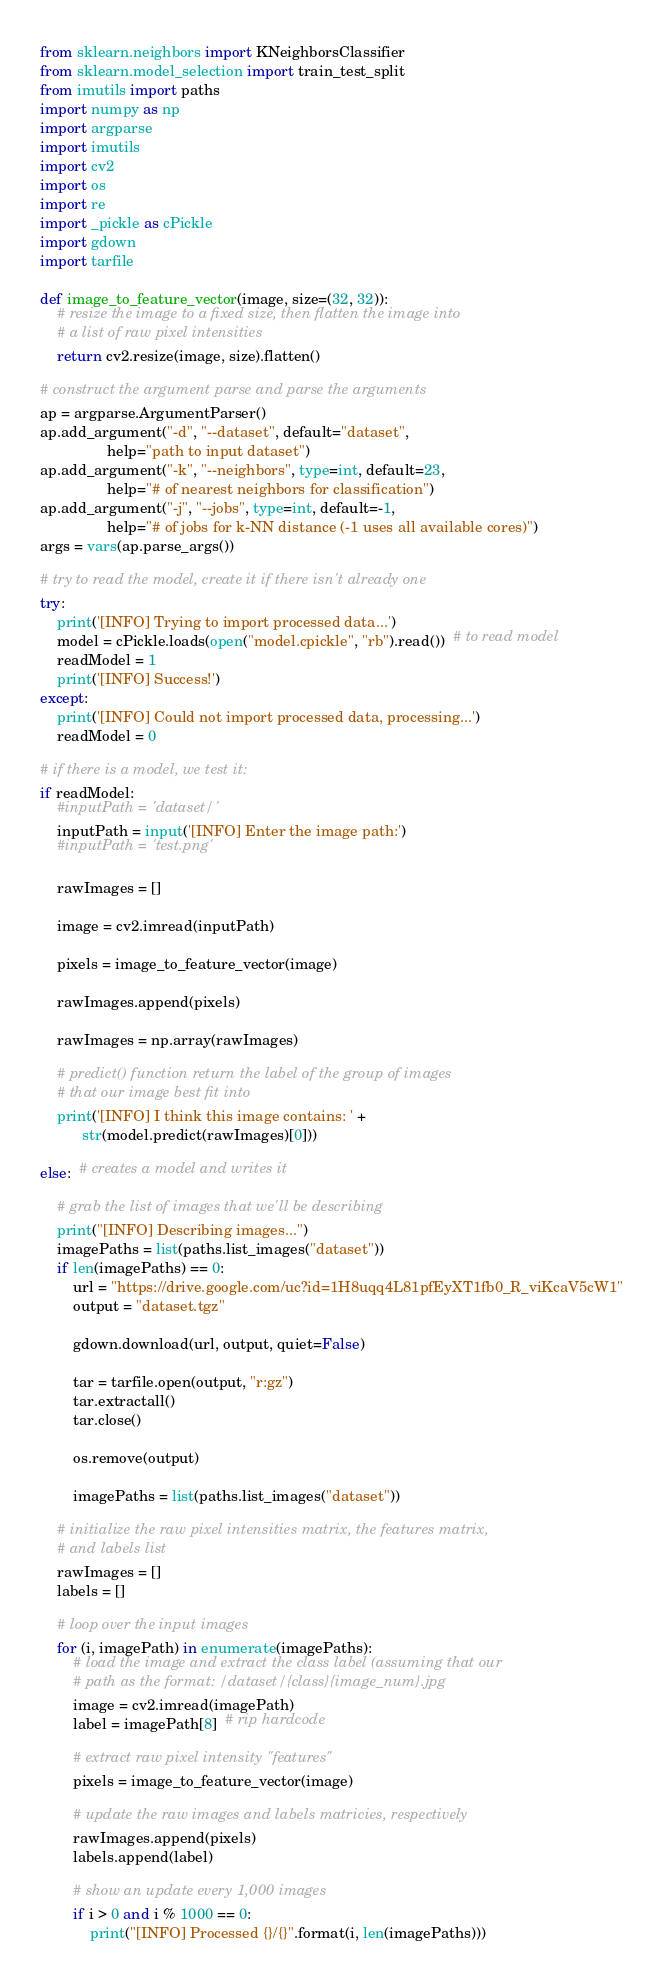Convert code to text. <code><loc_0><loc_0><loc_500><loc_500><_Python_>from sklearn.neighbors import KNeighborsClassifier
from sklearn.model_selection import train_test_split
from imutils import paths
import numpy as np
import argparse
import imutils
import cv2
import os
import re
import _pickle as cPickle
import gdown
import tarfile

def image_to_feature_vector(image, size=(32, 32)):
    # resize the image to a fixed size, then flatten the image into
    # a list of raw pixel intensities
    return cv2.resize(image, size).flatten()

# construct the argument parse and parse the arguments
ap = argparse.ArgumentParser()
ap.add_argument("-d", "--dataset", default="dataset",
                help="path to input dataset")
ap.add_argument("-k", "--neighbors", type=int, default=23,
                help="# of nearest neighbors for classification")
ap.add_argument("-j", "--jobs", type=int, default=-1,
                help="# of jobs for k-NN distance (-1 uses all available cores)")
args = vars(ap.parse_args())

# try to read the model, create it if there isn't already one
try:
    print('[INFO] Trying to import processed data...')
    model = cPickle.loads(open("model.cpickle", "rb").read())  # to read model
    readModel = 1
    print('[INFO] Success!')
except:
    print('[INFO] Could not import processed data, processing...')
    readModel = 0

# if there is a model, we test it:
if readModel:
    #inputPath = 'dataset/'
    inputPath = input('[INFO] Enter the image path:')
    #inputPath = 'test.png'

    rawImages = []

    image = cv2.imread(inputPath)

    pixels = image_to_feature_vector(image)

    rawImages.append(pixels)

    rawImages = np.array(rawImages)

    # predict() function return the label of the group of images
    # that our image best fit into
    print('[INFO] I think this image contains: ' +
          str(model.predict(rawImages)[0]))

else:  # creates a model and writes it

    # grab the list of images that we'll be describing
    print("[INFO] Describing images...")
    imagePaths = list(paths.list_images("dataset"))
    if len(imagePaths) == 0:
        url = "https://drive.google.com/uc?id=1H8uqq4L81pfEyXT1fb0_R_viKcaV5cW1"
        output = "dataset.tgz"

        gdown.download(url, output, quiet=False)

        tar = tarfile.open(output, "r:gz")
        tar.extractall()
        tar.close()

        os.remove(output)

        imagePaths = list(paths.list_images("dataset"))

    # initialize the raw pixel intensities matrix, the features matrix,
    # and labels list
    rawImages = []
    labels = []

    # loop over the input images
    for (i, imagePath) in enumerate(imagePaths):
        # load the image and extract the class label (assuming that our
        # path as the format: /dataset/{class}{image_num}.jpg
        image = cv2.imread(imagePath)
        label = imagePath[8]  # rip hardcode

        # extract raw pixel intensity "features"
        pixels = image_to_feature_vector(image)

        # update the raw images and labels matricies, respectively
        rawImages.append(pixels)
        labels.append(label)

        # show an update every 1,000 images
        if i > 0 and i % 1000 == 0:
            print("[INFO] Processed {}/{}".format(i, len(imagePaths)))
</code> 